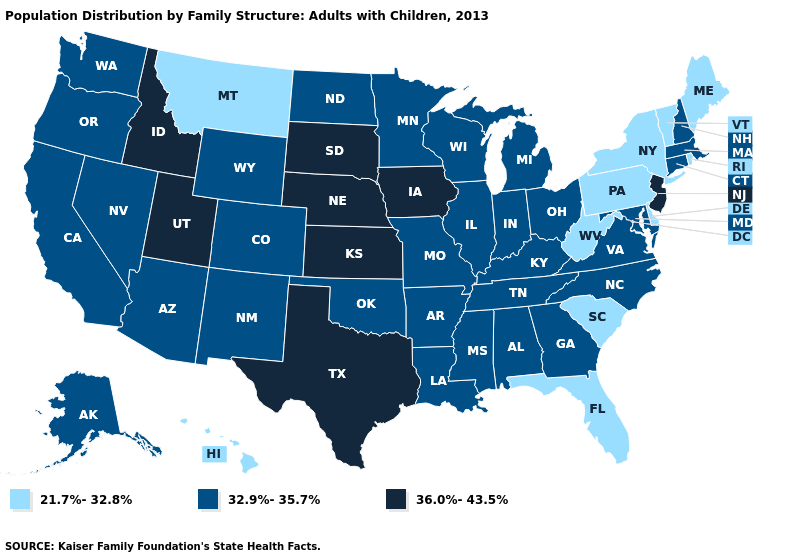Does Vermont have the same value as Montana?
Concise answer only. Yes. What is the highest value in states that border Idaho?
Answer briefly. 36.0%-43.5%. What is the highest value in the South ?
Quick response, please. 36.0%-43.5%. Does Michigan have the highest value in the USA?
Answer briefly. No. What is the highest value in the USA?
Write a very short answer. 36.0%-43.5%. Does the first symbol in the legend represent the smallest category?
Short answer required. Yes. What is the value of Oregon?
Give a very brief answer. 32.9%-35.7%. Does Arkansas have a higher value than Illinois?
Short answer required. No. Name the states that have a value in the range 36.0%-43.5%?
Keep it brief. Idaho, Iowa, Kansas, Nebraska, New Jersey, South Dakota, Texas, Utah. What is the lowest value in the USA?
Write a very short answer. 21.7%-32.8%. Does Massachusetts have a higher value than Louisiana?
Write a very short answer. No. Which states hav the highest value in the West?
Concise answer only. Idaho, Utah. Which states have the lowest value in the MidWest?
Keep it brief. Illinois, Indiana, Michigan, Minnesota, Missouri, North Dakota, Ohio, Wisconsin. What is the value of Virginia?
Be succinct. 32.9%-35.7%. Does Utah have a higher value than Illinois?
Be succinct. Yes. 